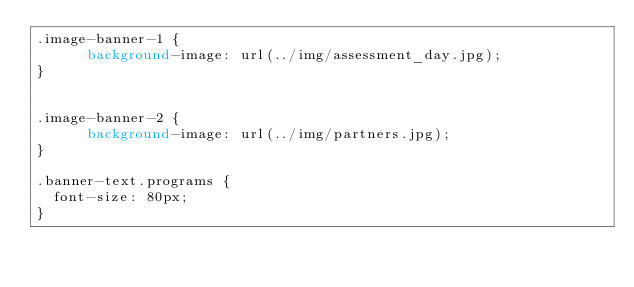<code> <loc_0><loc_0><loc_500><loc_500><_CSS_>.image-banner-1 {
      background-image: url(../img/assessment_day.jpg);
}


.image-banner-2 {
      background-image: url(../img/partners.jpg);
}

.banner-text.programs {
  font-size: 80px;
}
</code> 